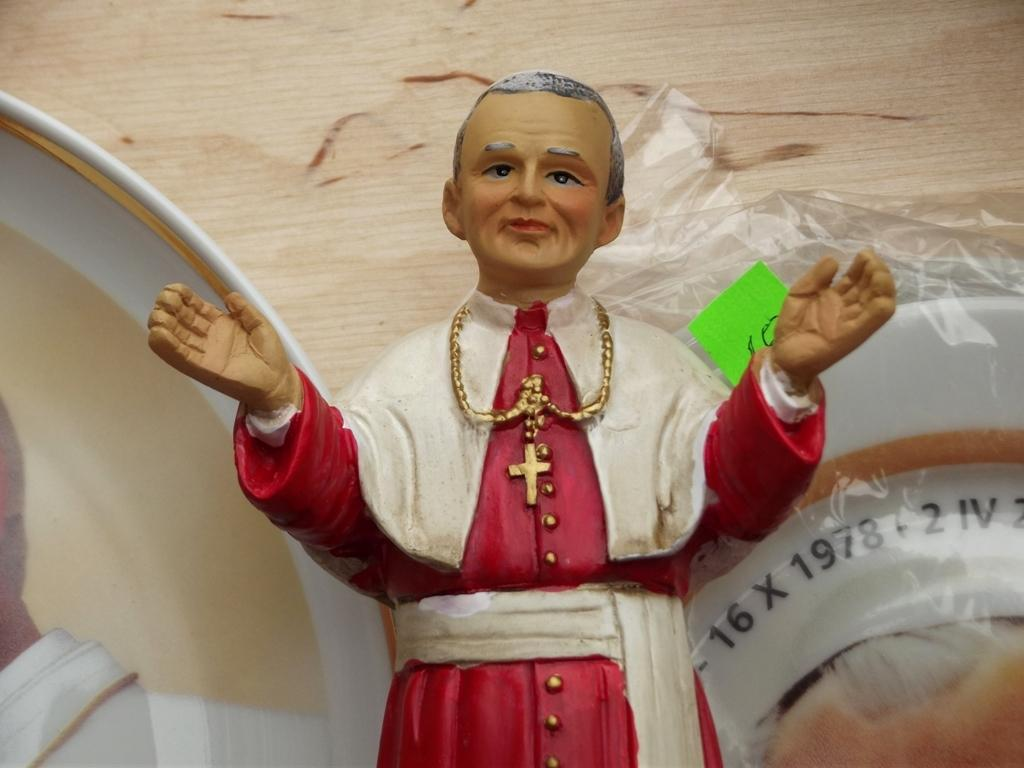What is the main subject of the image? The main subject of the image is a small toy of a church father. Are there any other objects in the image besides the toy? Yes, there are other objects behind the toy in the image. What type of patch can be seen on the clock in the image? There is no clock present in the image, so it is not possible to determine if there is a patch on it. 